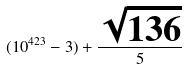<formula> <loc_0><loc_0><loc_500><loc_500>( 1 0 ^ { 4 2 3 } - 3 ) + \frac { \sqrt { 1 3 6 } } { 5 }</formula> 